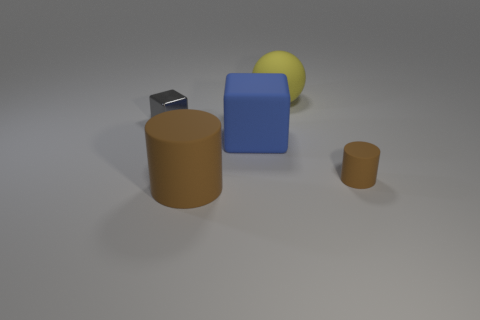Add 4 big cyan objects. How many objects exist? 9 Subtract all spheres. How many objects are left? 4 Subtract 2 cubes. How many cubes are left? 0 Add 4 balls. How many balls are left? 5 Add 3 small rubber cylinders. How many small rubber cylinders exist? 4 Subtract 0 cyan cubes. How many objects are left? 5 Subtract all blue blocks. Subtract all cyan cylinders. How many blocks are left? 1 Subtract all red spheres. How many blue blocks are left? 1 Subtract all small brown rubber cylinders. Subtract all brown objects. How many objects are left? 2 